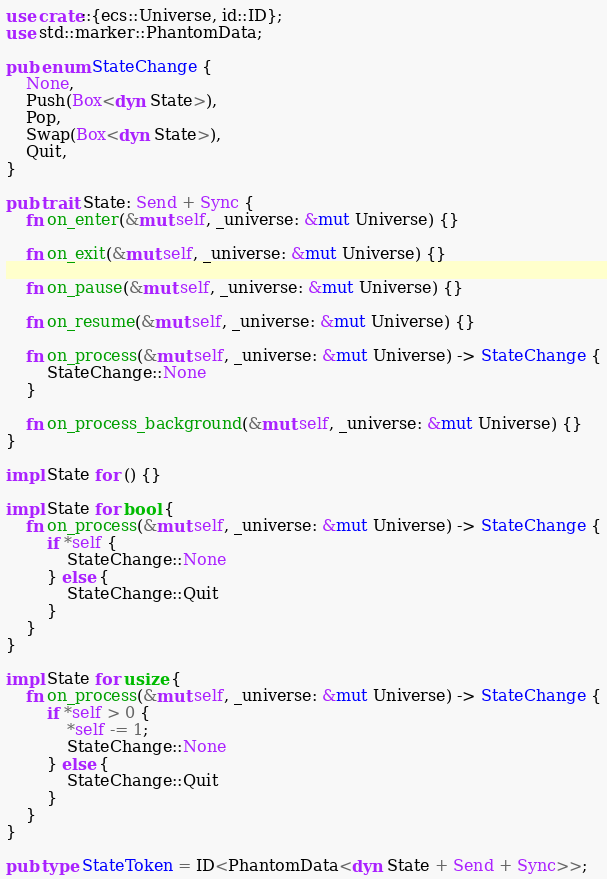Convert code to text. <code><loc_0><loc_0><loc_500><loc_500><_Rust_>use crate::{ecs::Universe, id::ID};
use std::marker::PhantomData;

pub enum StateChange {
    None,
    Push(Box<dyn State>),
    Pop,
    Swap(Box<dyn State>),
    Quit,
}

pub trait State: Send + Sync {
    fn on_enter(&mut self, _universe: &mut Universe) {}

    fn on_exit(&mut self, _universe: &mut Universe) {}

    fn on_pause(&mut self, _universe: &mut Universe) {}

    fn on_resume(&mut self, _universe: &mut Universe) {}

    fn on_process(&mut self, _universe: &mut Universe) -> StateChange {
        StateChange::None
    }

    fn on_process_background(&mut self, _universe: &mut Universe) {}
}

impl State for () {}

impl State for bool {
    fn on_process(&mut self, _universe: &mut Universe) -> StateChange {
        if *self {
            StateChange::None
        } else {
            StateChange::Quit
        }
    }
}

impl State for usize {
    fn on_process(&mut self, _universe: &mut Universe) -> StateChange {
        if *self > 0 {
            *self -= 1;
            StateChange::None
        } else {
            StateChange::Quit
        }
    }
}

pub type StateToken = ID<PhantomData<dyn State + Send + Sync>>;
</code> 